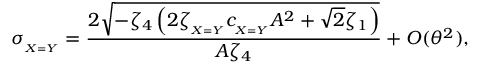Convert formula to latex. <formula><loc_0><loc_0><loc_500><loc_500>\sigma _ { _ { X = Y } } = \frac { 2 \sqrt { - \zeta _ { 4 } \left ( 2 \zeta _ { _ { X = Y } } c _ { _ { X = Y } } A ^ { 2 } + \sqrt { 2 } \zeta _ { 1 } \right ) } } { A \zeta _ { 4 } } + O ( \theta ^ { 2 } ) ,</formula> 